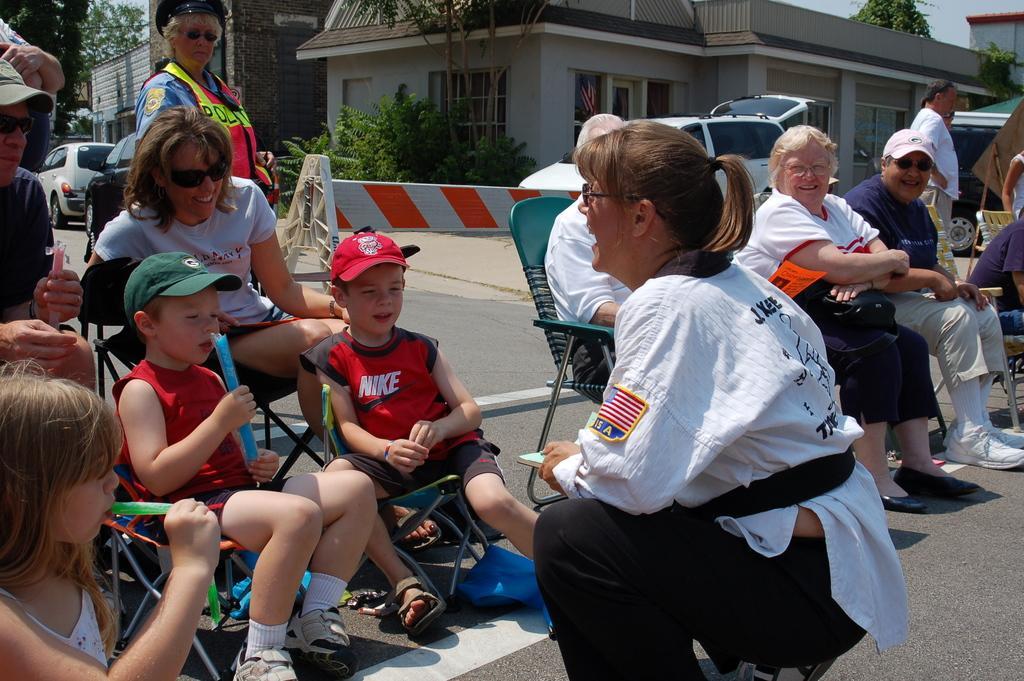In one or two sentences, can you explain what this image depicts? In this picture I can see group of people sitting on the chairs, there are few people standing, there are vehicles on the road, there is a barrier, and in the background there are buildings and trees. 